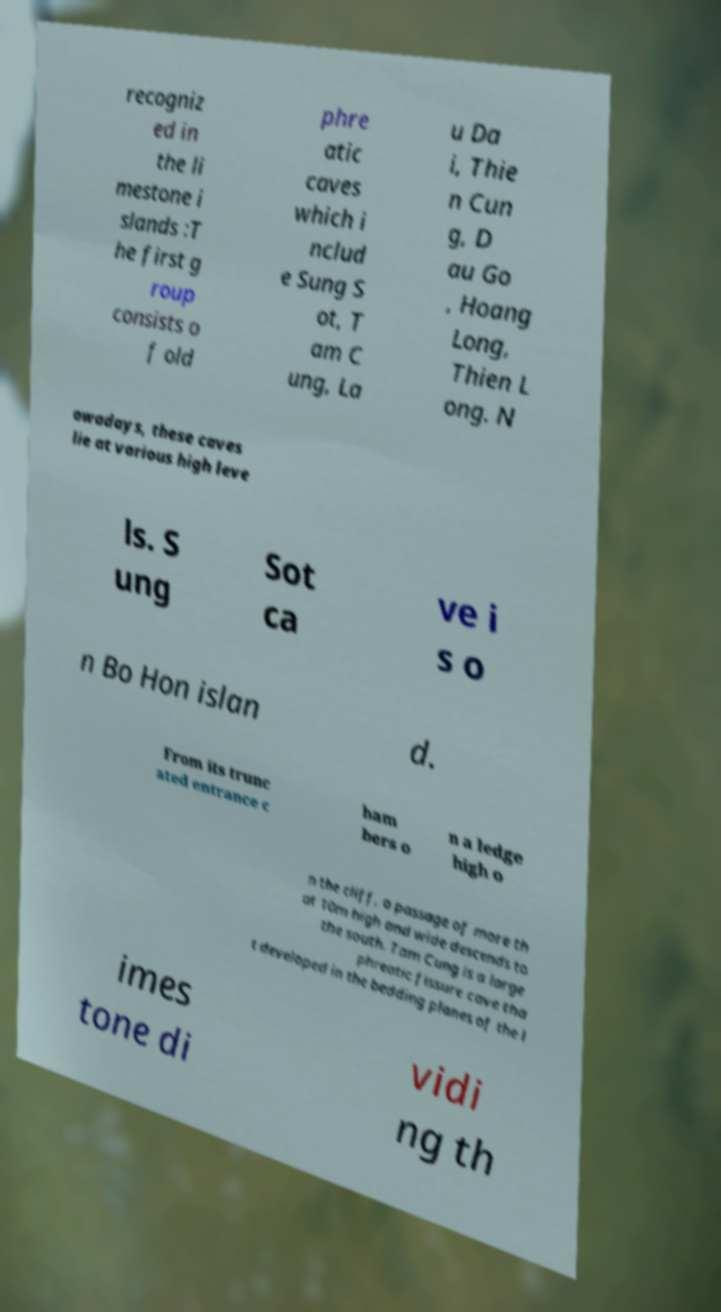For documentation purposes, I need the text within this image transcribed. Could you provide that? recogniz ed in the li mestone i slands :T he first g roup consists o f old phre atic caves which i nclud e Sung S ot, T am C ung, La u Da i, Thie n Cun g, D au Go , Hoang Long, Thien L ong. N owadays, these caves lie at various high leve ls. S ung Sot ca ve i s o n Bo Hon islan d. From its trunc ated entrance c ham bers o n a ledge high o n the cliff, a passage of more th at 10m high and wide descends to the south. Tam Cung is a large phreatic fissure cave tha t developed in the bedding planes of the l imes tone di vidi ng th 